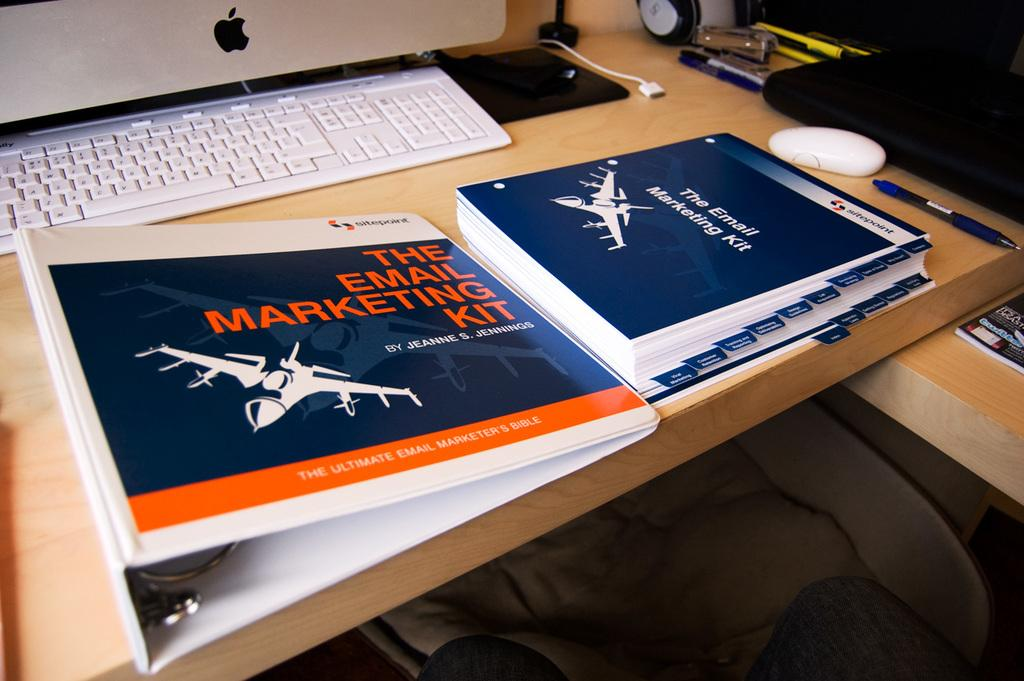<image>
Render a clear and concise summary of the photo. A white binder contains the email marketing kit. 